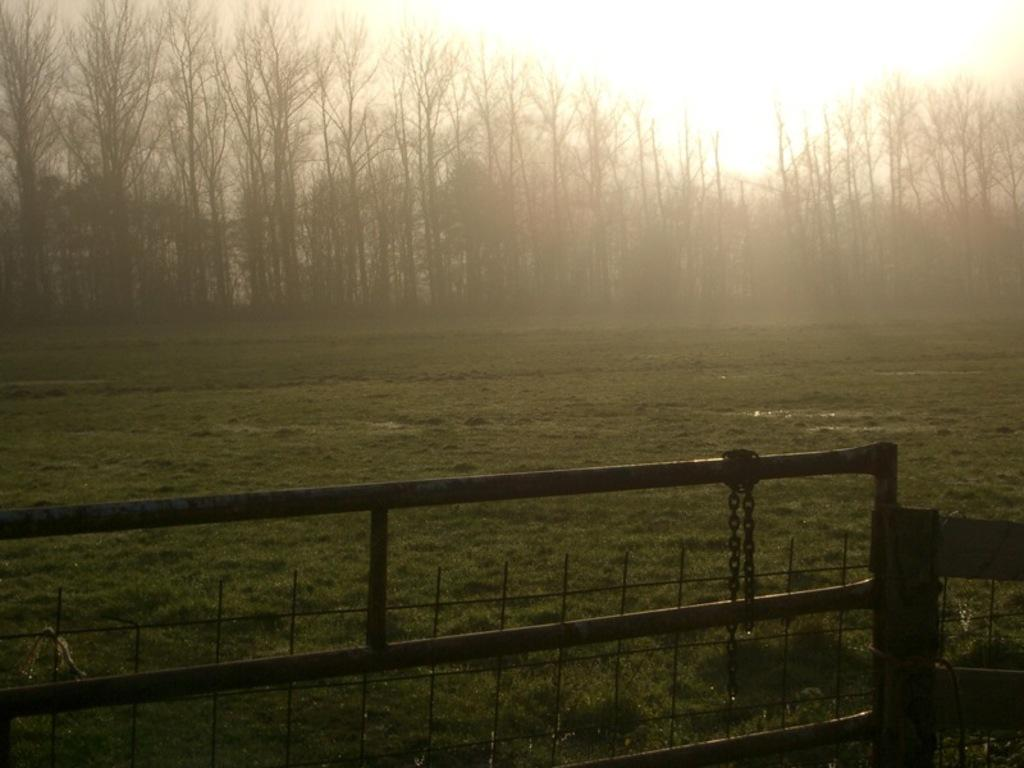What type of barrier is present in the image? There is an iron gate in the image. Is there anything attached to the iron gate? Yes, a chain is attached to the iron gate. What can be seen in the background of the image? There is a group of trees and the sky visible in the background of the image. How many legs does the net have in the image? There is no net present in the image. What phase is the moon in during the image? The image does not show the moon, so it is not possible to determine its phase. 